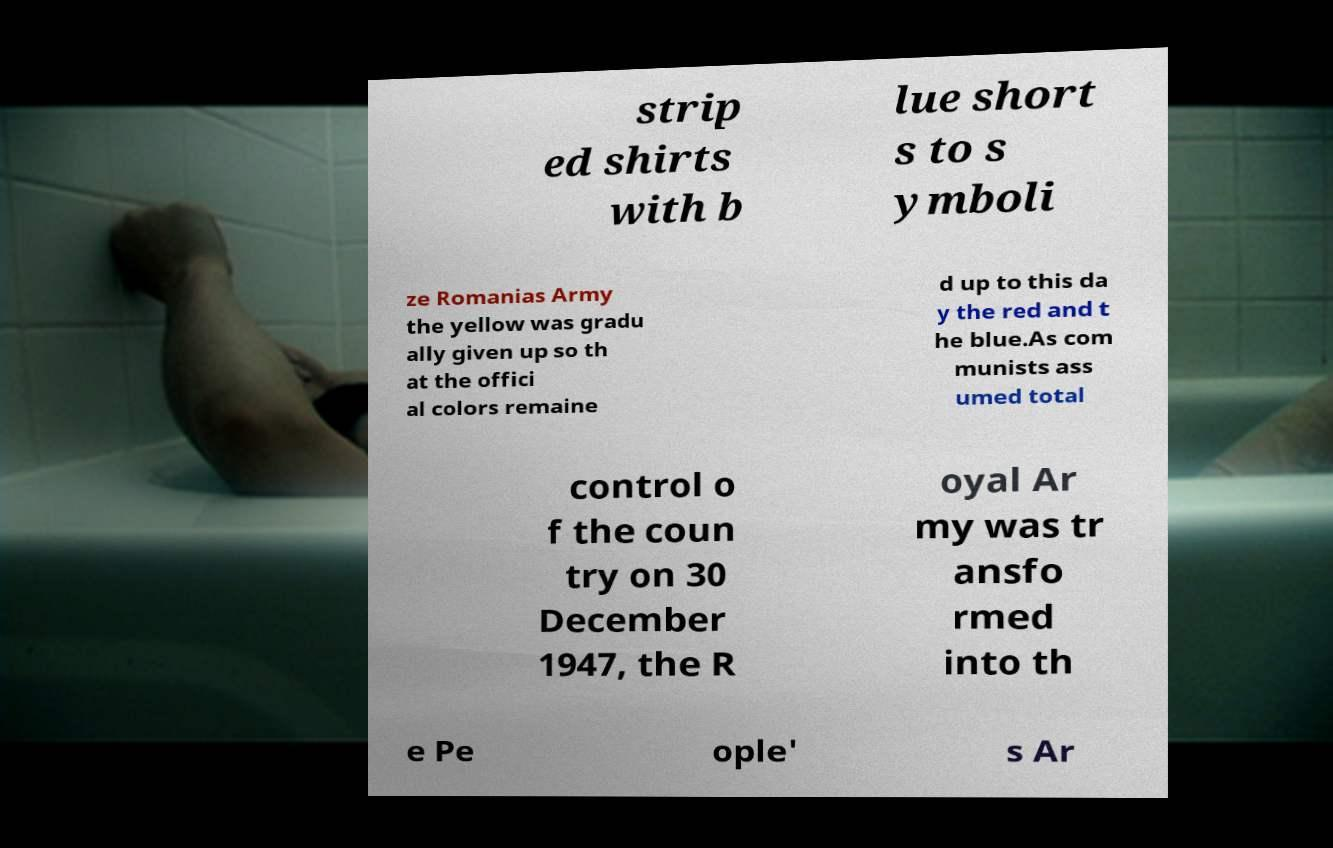Can you read and provide the text displayed in the image?This photo seems to have some interesting text. Can you extract and type it out for me? strip ed shirts with b lue short s to s ymboli ze Romanias Army the yellow was gradu ally given up so th at the offici al colors remaine d up to this da y the red and t he blue.As com munists ass umed total control o f the coun try on 30 December 1947, the R oyal Ar my was tr ansfo rmed into th e Pe ople' s Ar 